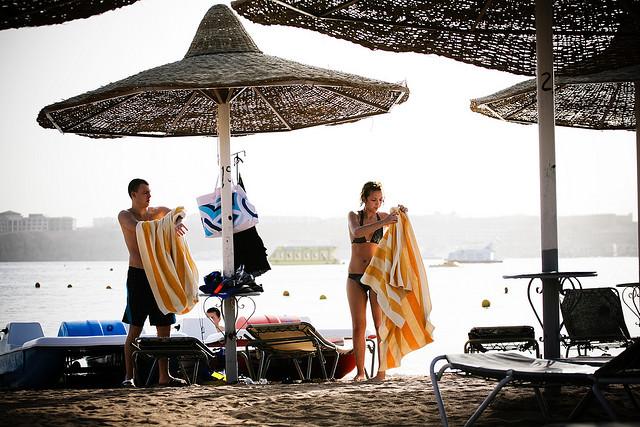What are the umbrellas made of?
Answer briefly. Straw. What colors are the towels?
Keep it brief. Yellow and white. What symbol do the supporting arms of the mini tables form?
Quick response, please. Heart. 